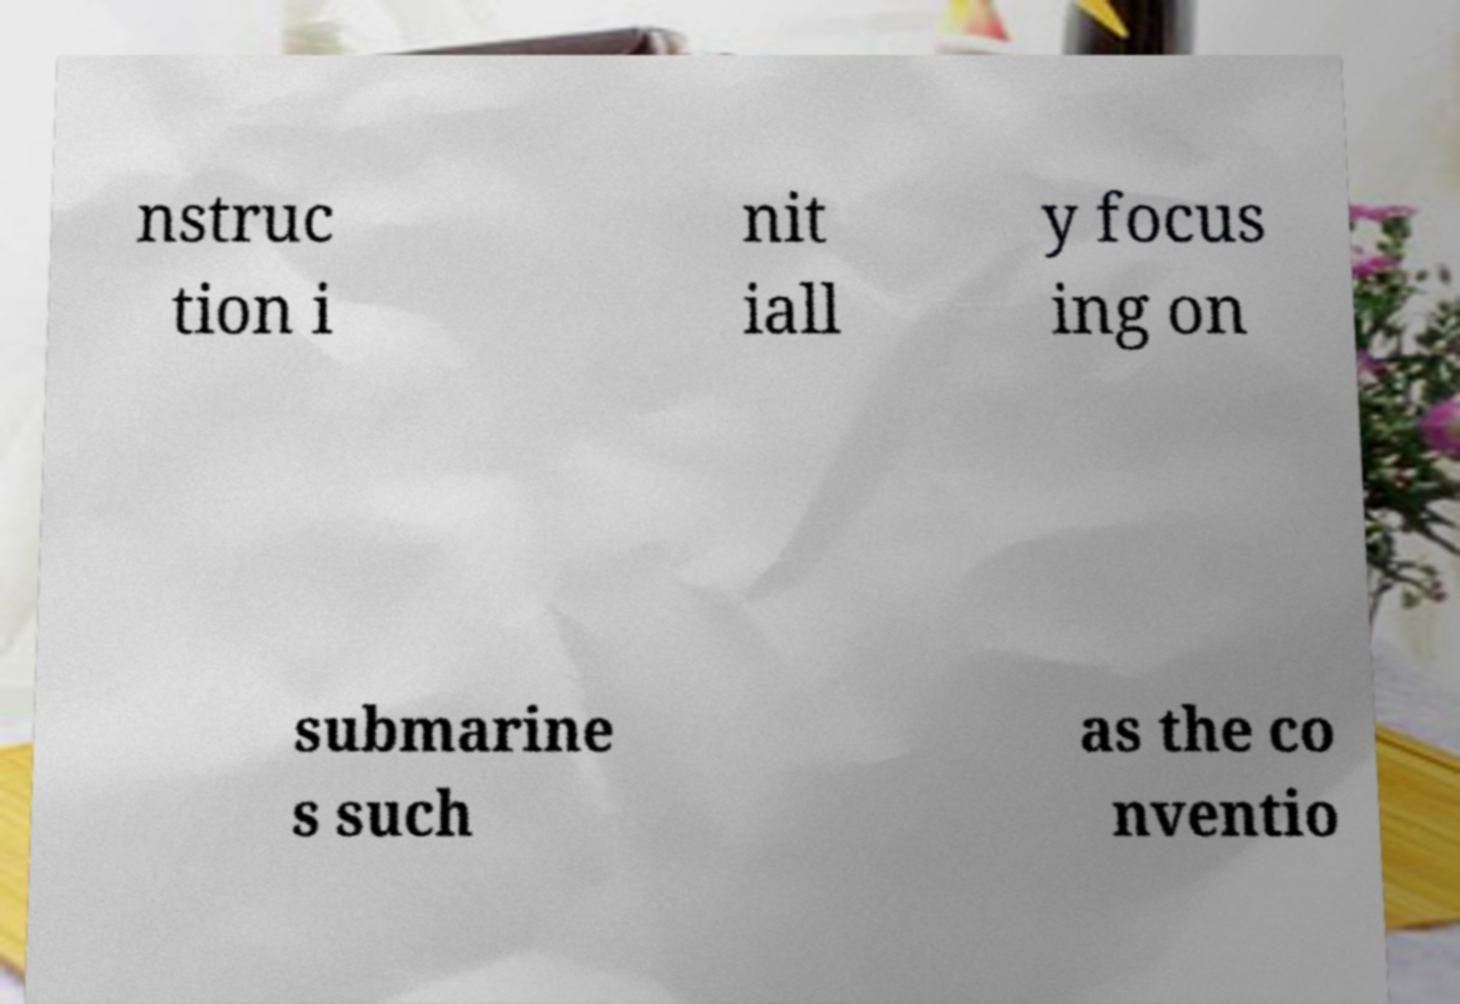For documentation purposes, I need the text within this image transcribed. Could you provide that? nstruc tion i nit iall y focus ing on submarine s such as the co nventio 